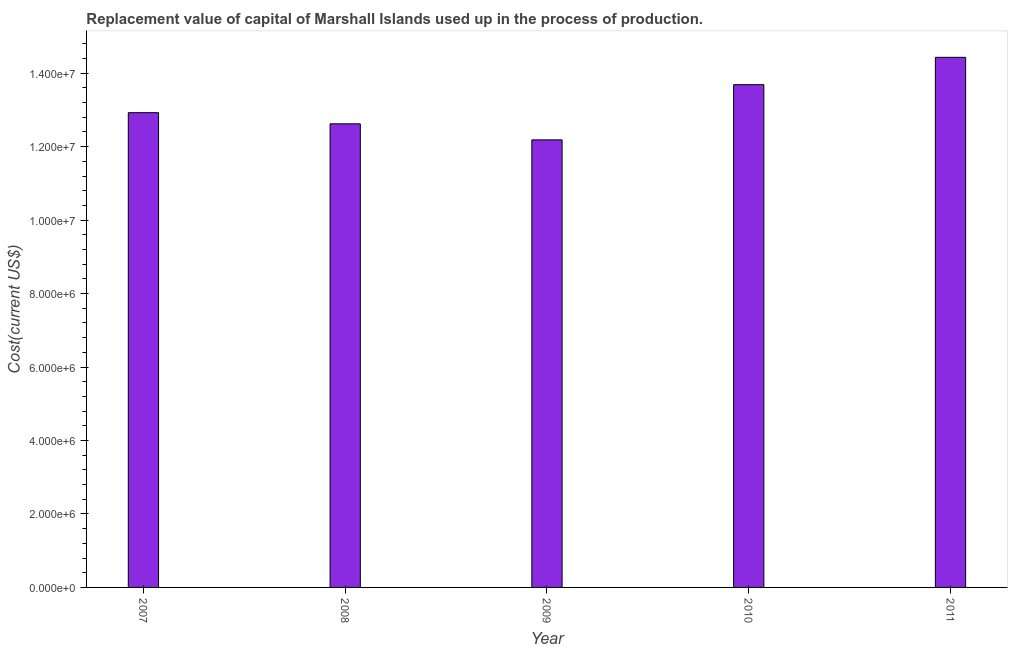Does the graph contain any zero values?
Offer a very short reply. No. What is the title of the graph?
Provide a short and direct response. Replacement value of capital of Marshall Islands used up in the process of production. What is the label or title of the Y-axis?
Keep it short and to the point. Cost(current US$). What is the consumption of fixed capital in 2009?
Your response must be concise. 1.22e+07. Across all years, what is the maximum consumption of fixed capital?
Give a very brief answer. 1.44e+07. Across all years, what is the minimum consumption of fixed capital?
Keep it short and to the point. 1.22e+07. In which year was the consumption of fixed capital maximum?
Your response must be concise. 2011. In which year was the consumption of fixed capital minimum?
Give a very brief answer. 2009. What is the sum of the consumption of fixed capital?
Provide a succinct answer. 6.58e+07. What is the difference between the consumption of fixed capital in 2008 and 2011?
Provide a succinct answer. -1.81e+06. What is the average consumption of fixed capital per year?
Give a very brief answer. 1.32e+07. What is the median consumption of fixed capital?
Your answer should be very brief. 1.29e+07. What is the ratio of the consumption of fixed capital in 2007 to that in 2008?
Ensure brevity in your answer.  1.02. Is the consumption of fixed capital in 2008 less than that in 2009?
Provide a short and direct response. No. Is the difference between the consumption of fixed capital in 2008 and 2010 greater than the difference between any two years?
Offer a very short reply. No. What is the difference between the highest and the second highest consumption of fixed capital?
Your answer should be compact. 7.44e+05. What is the difference between the highest and the lowest consumption of fixed capital?
Your answer should be very brief. 2.25e+06. In how many years, is the consumption of fixed capital greater than the average consumption of fixed capital taken over all years?
Give a very brief answer. 2. How many bars are there?
Offer a terse response. 5. Are all the bars in the graph horizontal?
Your response must be concise. No. What is the difference between two consecutive major ticks on the Y-axis?
Offer a very short reply. 2.00e+06. What is the Cost(current US$) of 2007?
Keep it short and to the point. 1.29e+07. What is the Cost(current US$) of 2008?
Your answer should be very brief. 1.26e+07. What is the Cost(current US$) of 2009?
Provide a short and direct response. 1.22e+07. What is the Cost(current US$) of 2010?
Your response must be concise. 1.37e+07. What is the Cost(current US$) in 2011?
Offer a terse response. 1.44e+07. What is the difference between the Cost(current US$) in 2007 and 2008?
Give a very brief answer. 3.03e+05. What is the difference between the Cost(current US$) in 2007 and 2009?
Offer a very short reply. 7.40e+05. What is the difference between the Cost(current US$) in 2007 and 2010?
Give a very brief answer. -7.63e+05. What is the difference between the Cost(current US$) in 2007 and 2011?
Keep it short and to the point. -1.51e+06. What is the difference between the Cost(current US$) in 2008 and 2009?
Make the answer very short. 4.37e+05. What is the difference between the Cost(current US$) in 2008 and 2010?
Your answer should be very brief. -1.07e+06. What is the difference between the Cost(current US$) in 2008 and 2011?
Your answer should be compact. -1.81e+06. What is the difference between the Cost(current US$) in 2009 and 2010?
Your answer should be compact. -1.50e+06. What is the difference between the Cost(current US$) in 2009 and 2011?
Give a very brief answer. -2.25e+06. What is the difference between the Cost(current US$) in 2010 and 2011?
Offer a terse response. -7.44e+05. What is the ratio of the Cost(current US$) in 2007 to that in 2008?
Make the answer very short. 1.02. What is the ratio of the Cost(current US$) in 2007 to that in 2009?
Give a very brief answer. 1.06. What is the ratio of the Cost(current US$) in 2007 to that in 2010?
Give a very brief answer. 0.94. What is the ratio of the Cost(current US$) in 2007 to that in 2011?
Ensure brevity in your answer.  0.9. What is the ratio of the Cost(current US$) in 2008 to that in 2009?
Keep it short and to the point. 1.04. What is the ratio of the Cost(current US$) in 2008 to that in 2010?
Offer a terse response. 0.92. What is the ratio of the Cost(current US$) in 2008 to that in 2011?
Provide a short and direct response. 0.88. What is the ratio of the Cost(current US$) in 2009 to that in 2010?
Provide a short and direct response. 0.89. What is the ratio of the Cost(current US$) in 2009 to that in 2011?
Ensure brevity in your answer.  0.84. What is the ratio of the Cost(current US$) in 2010 to that in 2011?
Make the answer very short. 0.95. 